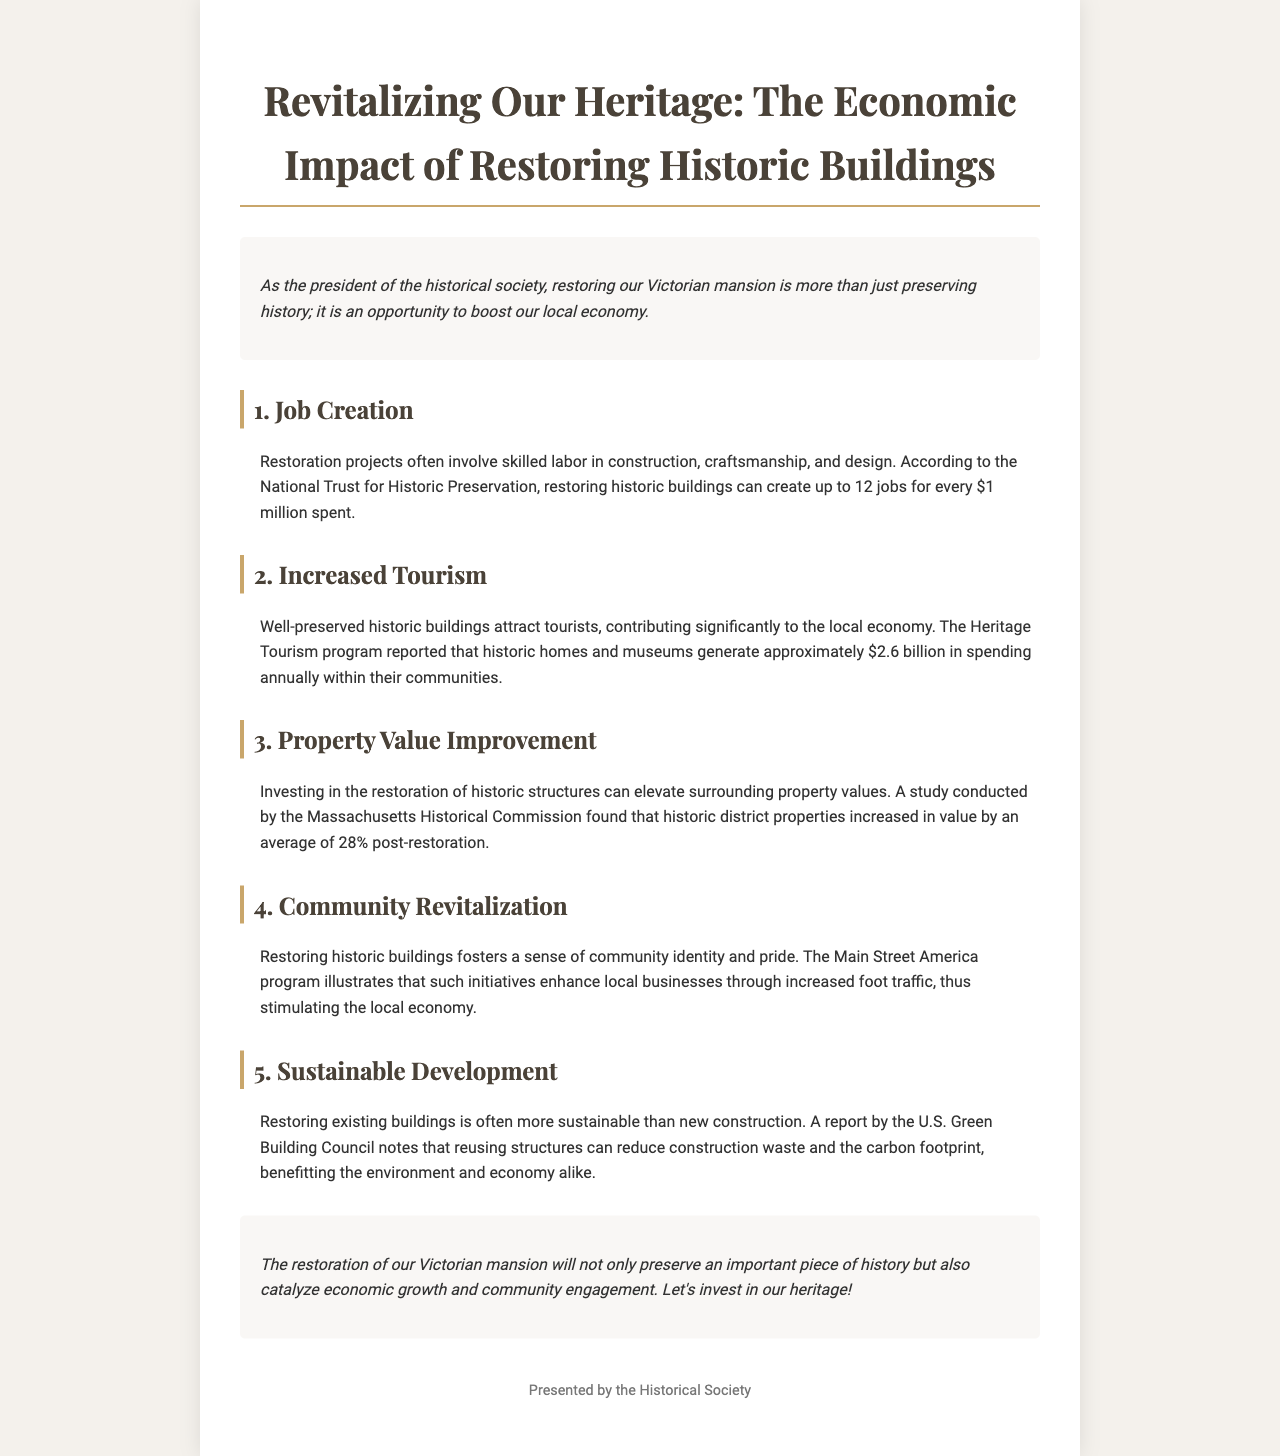What is the title of the brochure? The title of the brochure, as stated at the top, reflects its purpose and theme: "Revitalizing Our Heritage: The Economic Impact of Restoring Historic Buildings."
Answer: Revitalizing Our Heritage: The Economic Impact of Restoring Historic Buildings How many jobs can be created for every $1 million spent on restoration projects? The brochure cites a source that indicates restoration projects can create jobs, stating that up to 12 jobs can be generated for every $1 million spent.
Answer: 12 jobs What is the annual spending generated by historic homes and museums? According to the Heritage Tourism program information in the document, historic homes and museums collectively generate approximately $2.6 billion in annual spending.
Answer: $2.6 billion By what average percentage do historic district properties increase in value post-restoration? The document mentions a study by the Massachusetts Historical Commission that found an average property value increase of 28% post-restoration in historic districts.
Answer: 28% What major benefit does the Main Street America program highlight in relation to restored historic buildings? The brochure points out that the Main Street America program illustrates the enhancement of local businesses through increased foot traffic due to restored historic buildings.
Answer: Enhanced local businesses What is the environmental benefit of restoring existing buildings compared to new construction? The U.S. Green Building Council report in the brochure mentions that reusing structures can lead to reduced construction waste and a lower carbon footprint.
Answer: Reduced construction waste What is the overall conclusion regarding the restoration of the Victorian mansion? The conclusion in the brochure highlights that restoring the mansion will serve dual purposes: preserving heritage and catalyzing economic growth and community engagement.
Answer: Preserve heritage and catalyze economic growth What type of project is emphasized in the introduction of the brochure? The introduction emphasizes the project of restoring the Victorian mansion, highlighting its significance in preserving history while impacting the local economy.
Answer: Restoring the Victorian mansion 